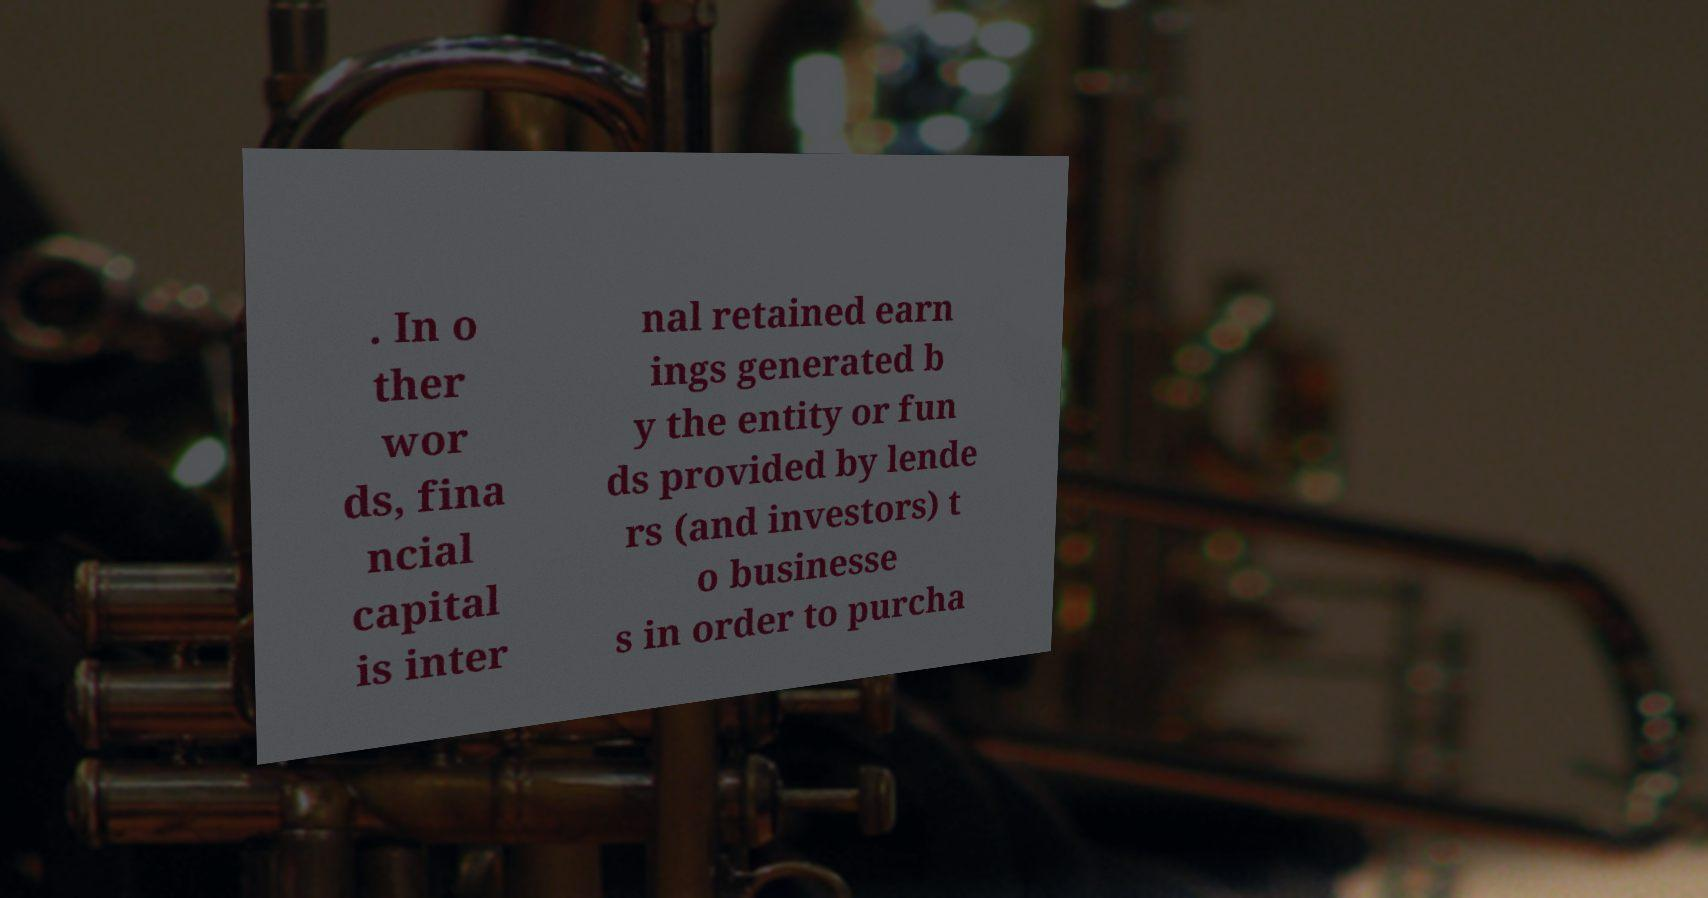What messages or text are displayed in this image? I need them in a readable, typed format. . In o ther wor ds, fina ncial capital is inter nal retained earn ings generated b y the entity or fun ds provided by lende rs (and investors) t o businesse s in order to purcha 